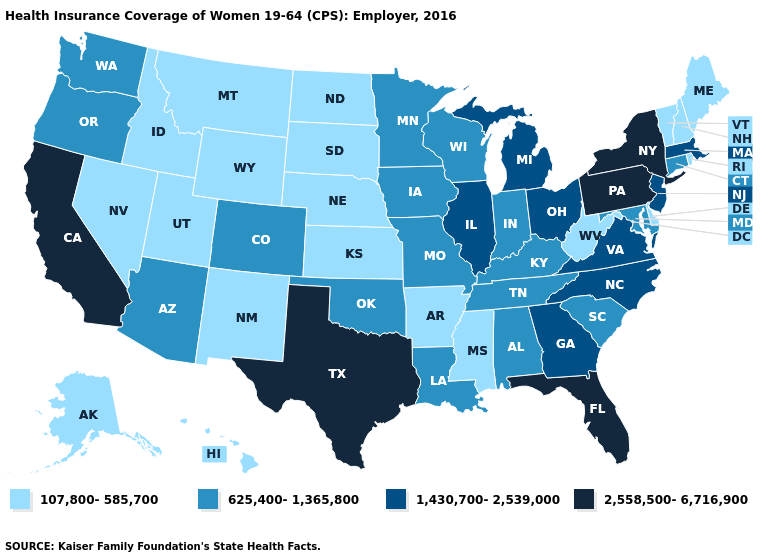Among the states that border Colorado , which have the highest value?
Answer briefly. Arizona, Oklahoma. Which states have the lowest value in the West?
Keep it brief. Alaska, Hawaii, Idaho, Montana, Nevada, New Mexico, Utah, Wyoming. Name the states that have a value in the range 107,800-585,700?
Short answer required. Alaska, Arkansas, Delaware, Hawaii, Idaho, Kansas, Maine, Mississippi, Montana, Nebraska, Nevada, New Hampshire, New Mexico, North Dakota, Rhode Island, South Dakota, Utah, Vermont, West Virginia, Wyoming. Among the states that border New York , does Vermont have the lowest value?
Give a very brief answer. Yes. What is the highest value in states that border Mississippi?
Keep it brief. 625,400-1,365,800. What is the value of North Dakota?
Answer briefly. 107,800-585,700. Does Georgia have the same value as New York?
Give a very brief answer. No. What is the value of Delaware?
Be succinct. 107,800-585,700. Does New Hampshire have the lowest value in the Northeast?
Answer briefly. Yes. What is the value of Delaware?
Concise answer only. 107,800-585,700. Does Hawaii have the lowest value in the USA?
Concise answer only. Yes. Name the states that have a value in the range 625,400-1,365,800?
Give a very brief answer. Alabama, Arizona, Colorado, Connecticut, Indiana, Iowa, Kentucky, Louisiana, Maryland, Minnesota, Missouri, Oklahoma, Oregon, South Carolina, Tennessee, Washington, Wisconsin. Does Rhode Island have the lowest value in the USA?
Keep it brief. Yes. Name the states that have a value in the range 107,800-585,700?
Answer briefly. Alaska, Arkansas, Delaware, Hawaii, Idaho, Kansas, Maine, Mississippi, Montana, Nebraska, Nevada, New Hampshire, New Mexico, North Dakota, Rhode Island, South Dakota, Utah, Vermont, West Virginia, Wyoming. Which states hav the highest value in the West?
Write a very short answer. California. 